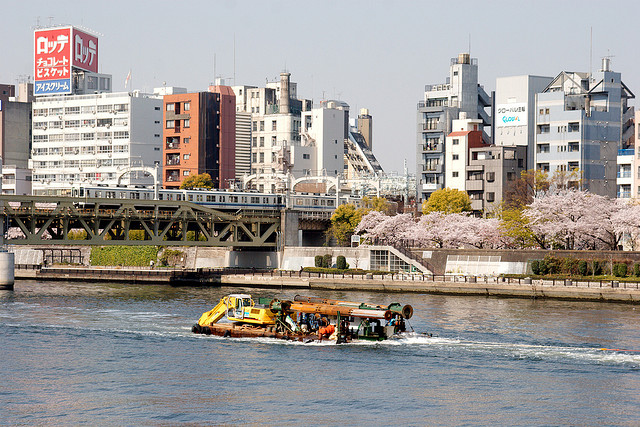Please identify all text content in this image. AYJ AYJ 